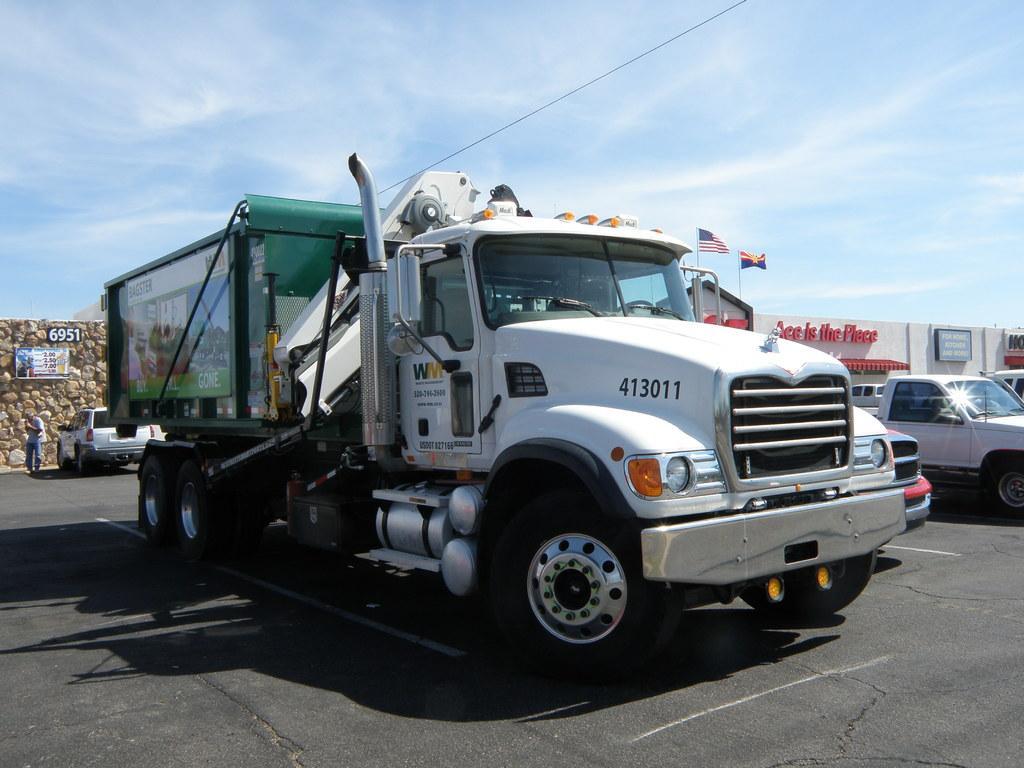Describe this image in one or two sentences. This image is taken outdoors. At the top of the image there is a sky with clouds. At the bottom of the image there is a road. In the background there is a wall and there is a board with a text on it. There is a house and there are many boards with text on them and there are two flags. On the left side of the image a car is parked on the road and a man is standing on the road. In the middle of the image a truck and a few cars are parked on the road. 